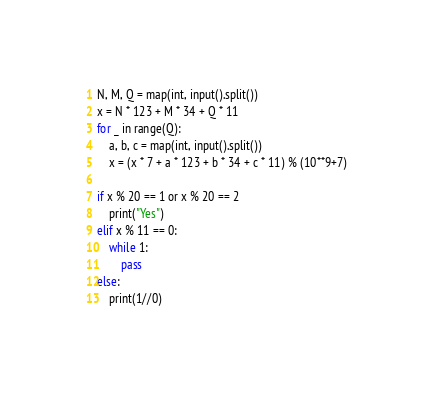Convert code to text. <code><loc_0><loc_0><loc_500><loc_500><_Python_>N, M, Q = map(int, input().split())
x = N * 123 + M * 34 + Q * 11
for _ in range(Q):
    a, b, c = map(int, input().split())
    x = (x * 7 + a * 123 + b * 34 + c * 11) % (10**9+7)

if x % 20 == 1 or x % 20 == 2
    print("Yes")
elif x % 11 == 0:
    while 1:
        pass
else:
    print(1//0)
</code> 